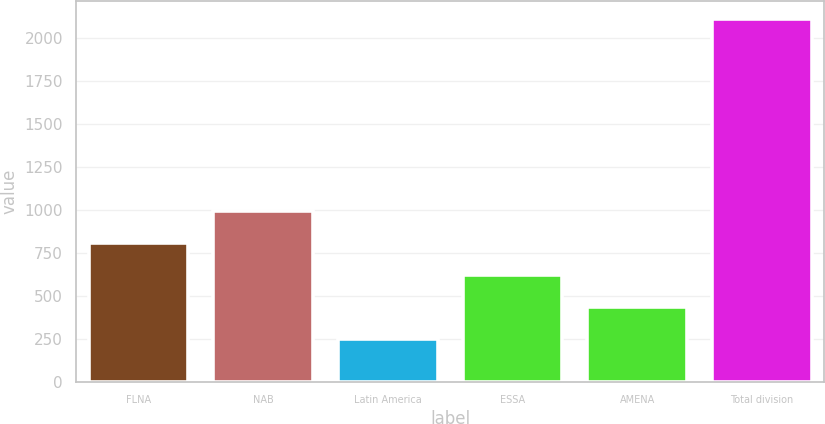<chart> <loc_0><loc_0><loc_500><loc_500><bar_chart><fcel>FLNA<fcel>NAB<fcel>Latin America<fcel>ESSA<fcel>AMENA<fcel>Total division<nl><fcel>803.6<fcel>989.8<fcel>245<fcel>617.4<fcel>431.2<fcel>2107<nl></chart> 